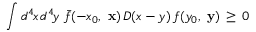Convert formula to latex. <formula><loc_0><loc_0><loc_500><loc_500>\int d ^ { 4 } \, x \, d ^ { 4 } \, y \, \bar { f } ( - x _ { 0 } , x ) \, D ( x - y ) \, f ( y _ { 0 } , y ) \, \geq \, 0</formula> 